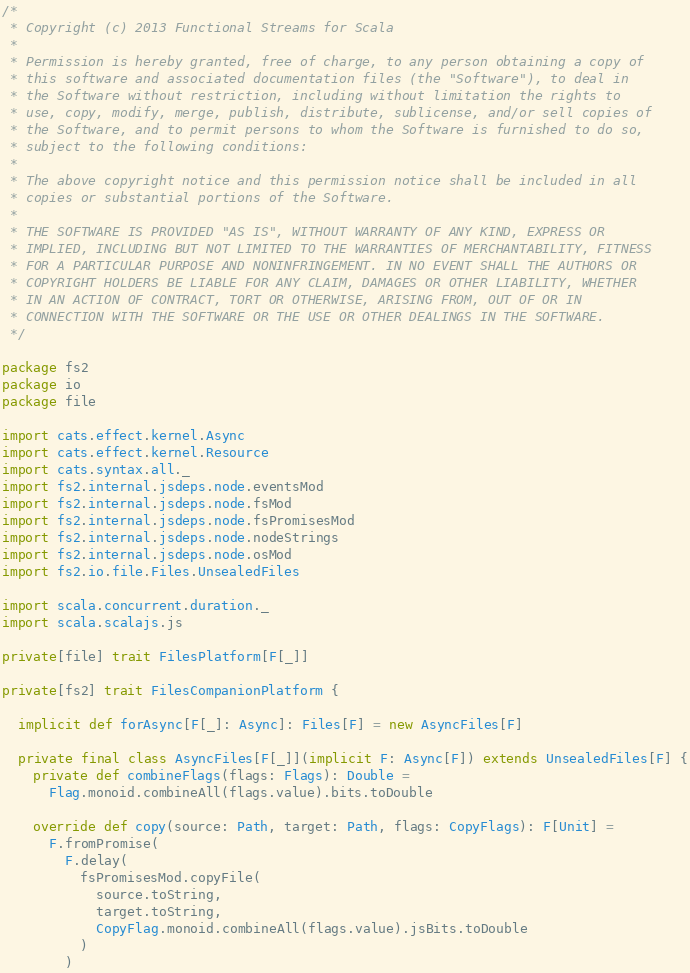<code> <loc_0><loc_0><loc_500><loc_500><_Scala_>/*
 * Copyright (c) 2013 Functional Streams for Scala
 *
 * Permission is hereby granted, free of charge, to any person obtaining a copy of
 * this software and associated documentation files (the "Software"), to deal in
 * the Software without restriction, including without limitation the rights to
 * use, copy, modify, merge, publish, distribute, sublicense, and/or sell copies of
 * the Software, and to permit persons to whom the Software is furnished to do so,
 * subject to the following conditions:
 *
 * The above copyright notice and this permission notice shall be included in all
 * copies or substantial portions of the Software.
 *
 * THE SOFTWARE IS PROVIDED "AS IS", WITHOUT WARRANTY OF ANY KIND, EXPRESS OR
 * IMPLIED, INCLUDING BUT NOT LIMITED TO THE WARRANTIES OF MERCHANTABILITY, FITNESS
 * FOR A PARTICULAR PURPOSE AND NONINFRINGEMENT. IN NO EVENT SHALL THE AUTHORS OR
 * COPYRIGHT HOLDERS BE LIABLE FOR ANY CLAIM, DAMAGES OR OTHER LIABILITY, WHETHER
 * IN AN ACTION OF CONTRACT, TORT OR OTHERWISE, ARISING FROM, OUT OF OR IN
 * CONNECTION WITH THE SOFTWARE OR THE USE OR OTHER DEALINGS IN THE SOFTWARE.
 */

package fs2
package io
package file

import cats.effect.kernel.Async
import cats.effect.kernel.Resource
import cats.syntax.all._
import fs2.internal.jsdeps.node.eventsMod
import fs2.internal.jsdeps.node.fsMod
import fs2.internal.jsdeps.node.fsPromisesMod
import fs2.internal.jsdeps.node.nodeStrings
import fs2.internal.jsdeps.node.osMod
import fs2.io.file.Files.UnsealedFiles

import scala.concurrent.duration._
import scala.scalajs.js

private[file] trait FilesPlatform[F[_]]

private[fs2] trait FilesCompanionPlatform {

  implicit def forAsync[F[_]: Async]: Files[F] = new AsyncFiles[F]

  private final class AsyncFiles[F[_]](implicit F: Async[F]) extends UnsealedFiles[F] {
    private def combineFlags(flags: Flags): Double =
      Flag.monoid.combineAll(flags.value).bits.toDouble

    override def copy(source: Path, target: Path, flags: CopyFlags): F[Unit] =
      F.fromPromise(
        F.delay(
          fsPromisesMod.copyFile(
            source.toString,
            target.toString,
            CopyFlag.monoid.combineAll(flags.value).jsBits.toDouble
          )
        )</code> 